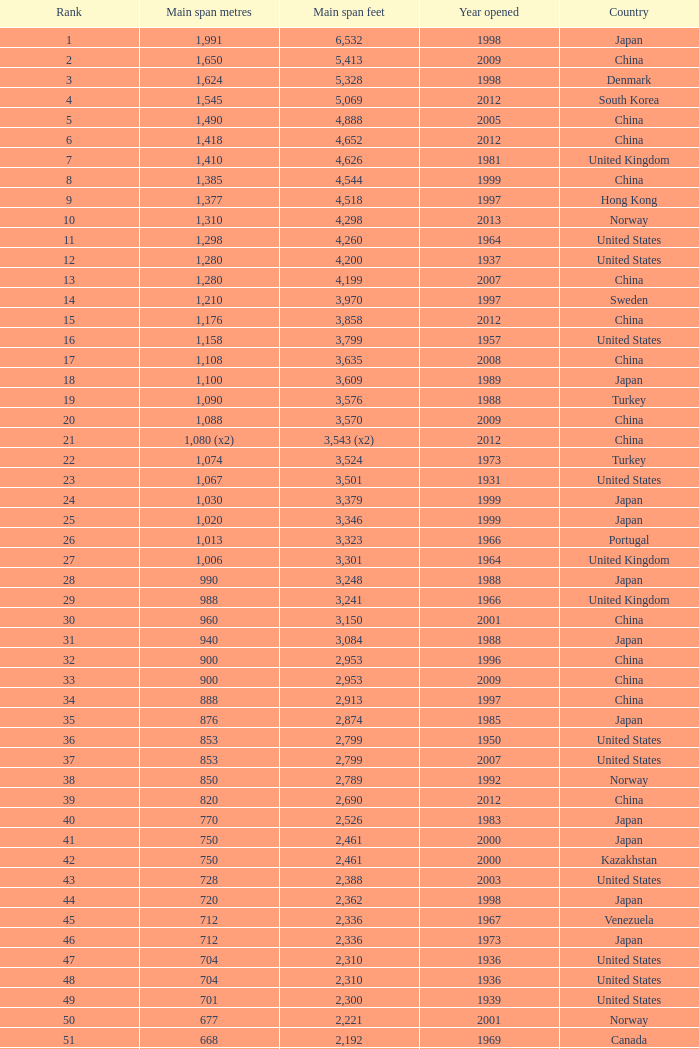In south korea, what is the oldest year that has a central span measuring 1,640 feet? 2002.0. 